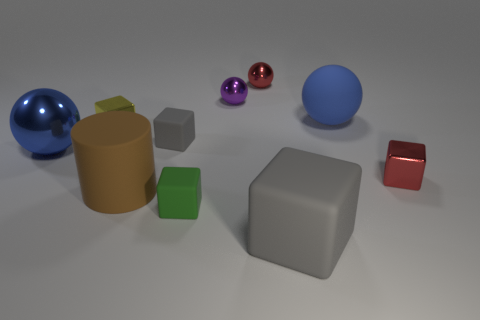Subtract all large rubber spheres. How many spheres are left? 3 Subtract all blue cubes. How many blue spheres are left? 2 Subtract all red blocks. How many blocks are left? 4 Subtract 1 balls. How many balls are left? 3 Subtract all green spheres. Subtract all yellow cubes. How many spheres are left? 4 Subtract all blue rubber spheres. Subtract all small blocks. How many objects are left? 5 Add 3 big brown matte objects. How many big brown matte objects are left? 4 Add 8 big gray matte objects. How many big gray matte objects exist? 9 Subtract 1 blue spheres. How many objects are left? 9 Subtract all cylinders. How many objects are left? 9 